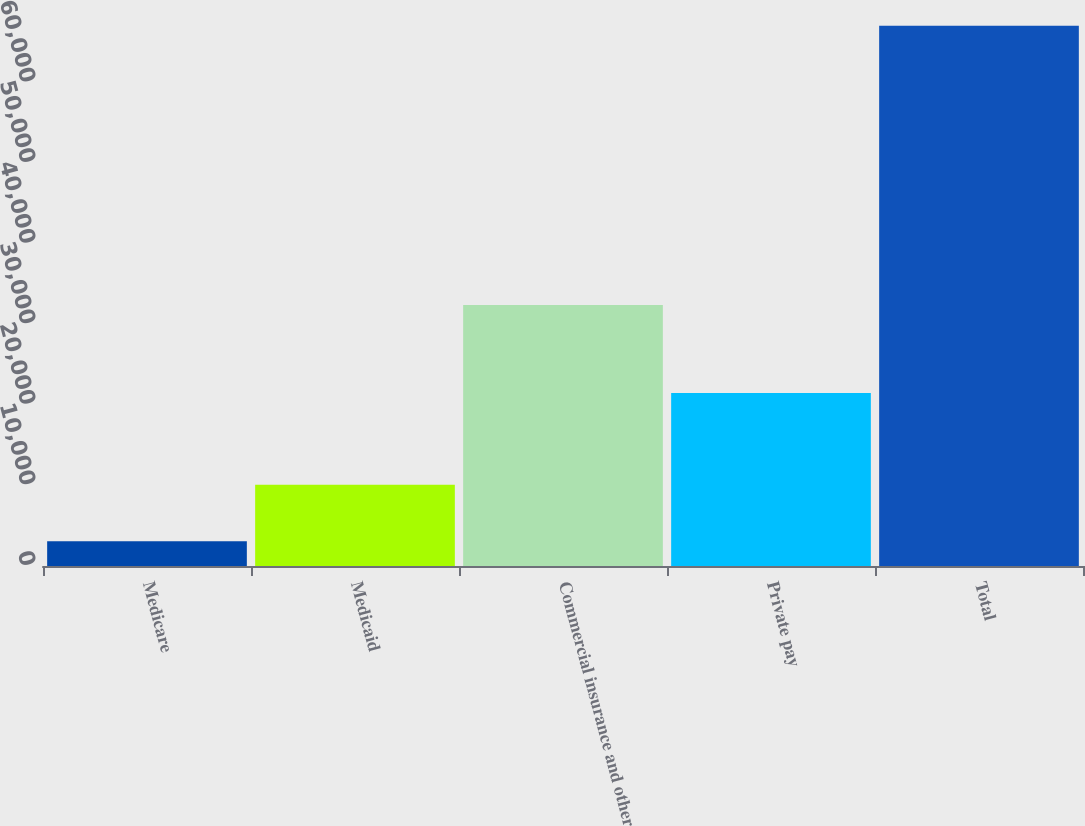Convert chart. <chart><loc_0><loc_0><loc_500><loc_500><bar_chart><fcel>Medicare<fcel>Medicaid<fcel>Commercial insurance and other<fcel>Private pay<fcel>Total<nl><fcel>3085<fcel>10095<fcel>32393<fcel>21483<fcel>67056<nl></chart> 